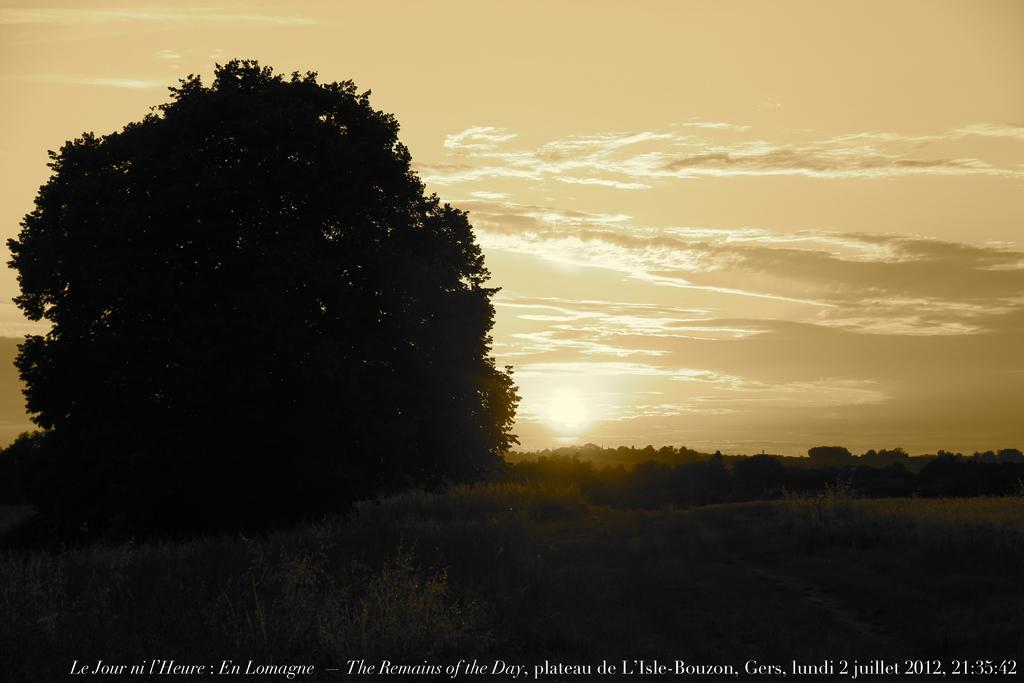What can be found at the bottom of the image? There is text at the bottom of the image. What type of natural elements are present in the image? There are trees in the middle of the image. What is visible at the top of the image? The sky is visible at the top of the image. Can you see any toes in the image? There are no toes visible in the image. Is there a lake present in the image? There is no lake present in the image. 